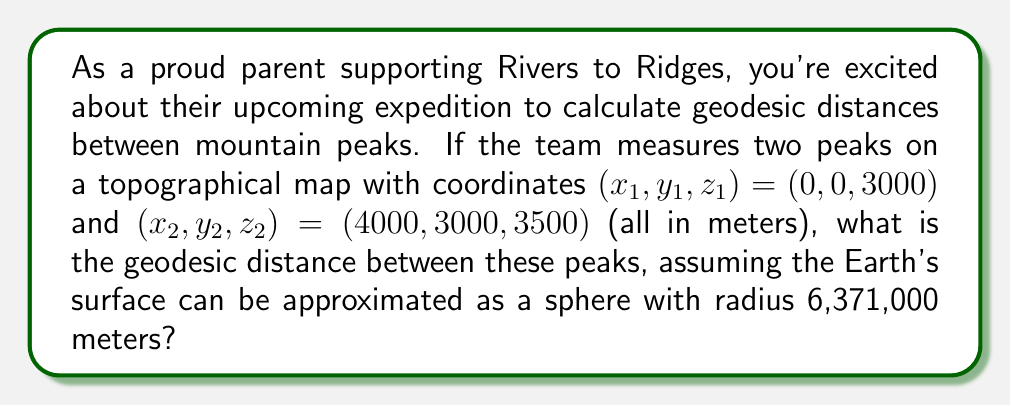Help me with this question. Let's approach this step-by-step:

1) First, we need to convert the Cartesian coordinates to spherical coordinates (latitude and longitude). We'll use the Earth's center as the origin.

2) The radial distance $r$ from the Earth's center to each point is:
   $$r_1 = 6371000 + 3000 = 6374000\text{ m}$$
   $$r_2 = 6371000 + 3500 = 6374500\text{ m}$$

3) The latitude $\phi$ and longitude $\lambda$ for each point can be calculated as:
   $$\phi_1 = \arcsin(\frac{3000}{6374000}) \approx 0.0270\text{ rad}$$
   $$\lambda_1 = \arctan(\frac{0}{0}) = 0\text{ rad}$$
   $$\phi_2 = \arcsin(\frac{3500}{6374500}) \approx 0.0315\text{ rad}$$
   $$\lambda_2 = \arctan(\frac{3000}{4000}) \approx 0.6435\text{ rad}$$

4) Now we can use the spherical law of cosines to calculate the central angle $\Delta\sigma$ between the two points:
   $$\cos(\Delta\sigma) = \sin(\phi_1)\sin(\phi_2) + \cos(\phi_1)\cos(\phi_2)\cos(\Delta\lambda)$$
   where $\Delta\lambda = |\lambda_2 - \lambda_1| = 0.6435$

5) Plugging in the values:
   $$\cos(\Delta\sigma) = \sin(0.0270)\sin(0.0315) + \cos(0.0270)\cos(0.0315)\cos(0.6435)$$
   $$\cos(\Delta\sigma) \approx 0.7996$$

6) Taking the arccos of both sides:
   $$\Delta\sigma \approx 0.6435\text{ rad}$$

7) The geodesic distance $d$ is then the arc length:
   $$d = R\Delta\sigma$$
   where $R$ is the average radius of the two points:
   $$R = \frac{6374000 + 6374500}{2} = 6374250\text{ m}$$

8) Therefore, the geodesic distance is:
   $$d = 6374250 \times 0.6435 \approx 4101836\text{ m}$$
Answer: $4101.84\text{ km}$ 